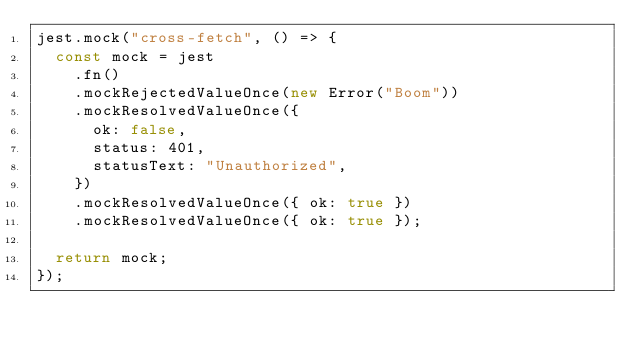<code> <loc_0><loc_0><loc_500><loc_500><_JavaScript_>jest.mock("cross-fetch", () => {
  const mock = jest
    .fn()
    .mockRejectedValueOnce(new Error("Boom"))
    .mockResolvedValueOnce({
      ok: false,
      status: 401,
      statusText: "Unauthorized",
    })
    .mockResolvedValueOnce({ ok: true })
    .mockResolvedValueOnce({ ok: true });

  return mock;
});
</code> 